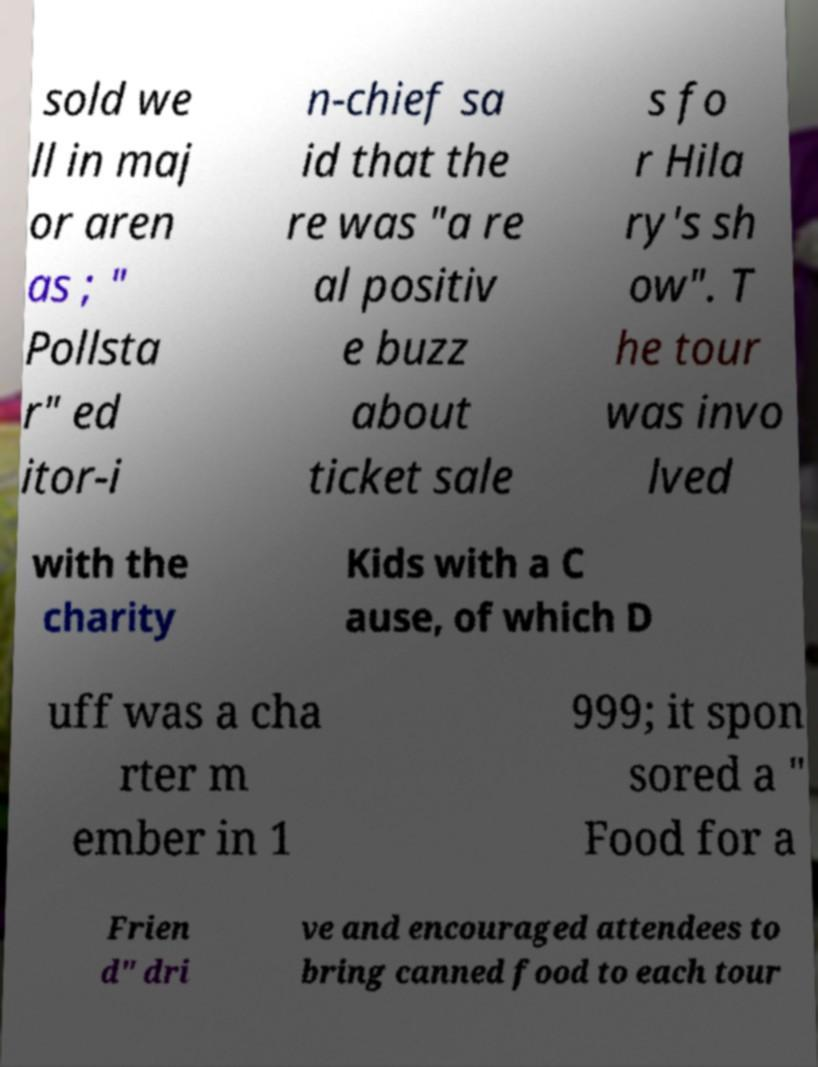Can you accurately transcribe the text from the provided image for me? sold we ll in maj or aren as ; " Pollsta r" ed itor-i n-chief sa id that the re was "a re al positiv e buzz about ticket sale s fo r Hila ry's sh ow". T he tour was invo lved with the charity Kids with a C ause, of which D uff was a cha rter m ember in 1 999; it spon sored a " Food for a Frien d" dri ve and encouraged attendees to bring canned food to each tour 